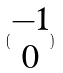Convert formula to latex. <formula><loc_0><loc_0><loc_500><loc_500>( \begin{matrix} - 1 \\ 0 \end{matrix} )</formula> 